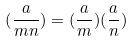<formula> <loc_0><loc_0><loc_500><loc_500>( \frac { a } { m n } ) = ( \frac { a } { m } ) ( \frac { a } { n } )</formula> 